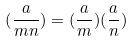<formula> <loc_0><loc_0><loc_500><loc_500>( \frac { a } { m n } ) = ( \frac { a } { m } ) ( \frac { a } { n } )</formula> 